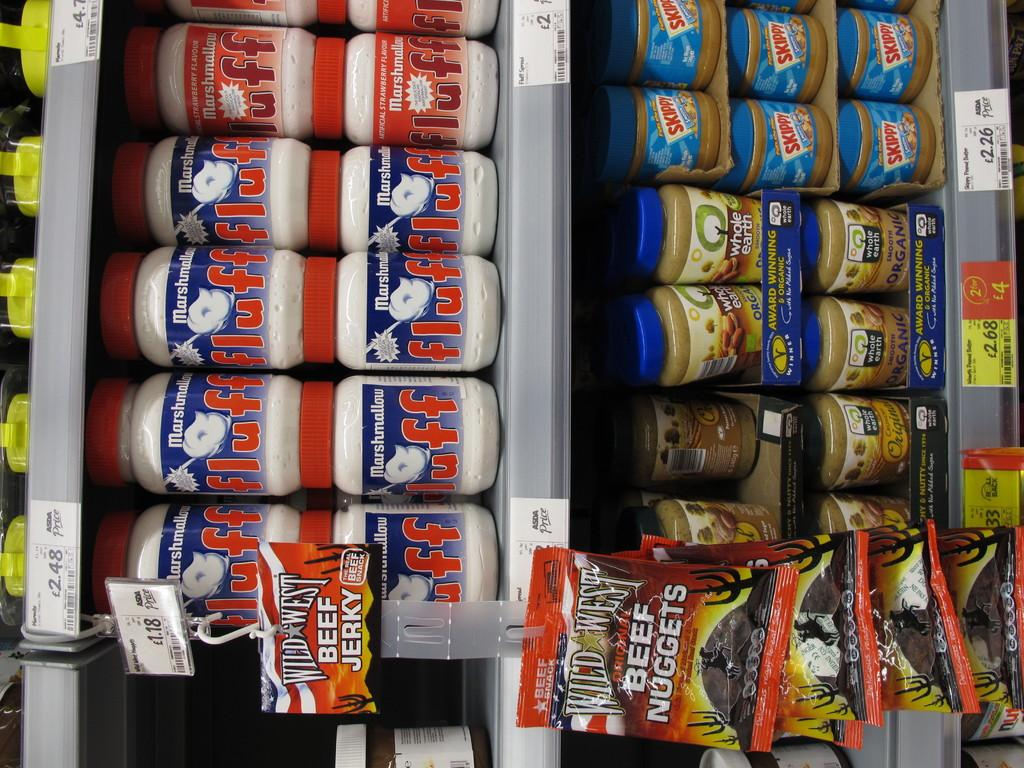What is the main subject of the image? The main subject of the image is a group of bottles. Where are the bottles located in the image? The bottles are placed on shelves in the image. What else can be seen in the image besides the bottles? There are packets in the image. How are the packets arranged in the image? The packets are hung aside in the image. What type of tax is being discussed in the image? There is no discussion of tax in the image; it features a group of bottles on shelves and packets hung aside. Can you see a goose in the image? No, there is no goose present in the image. 